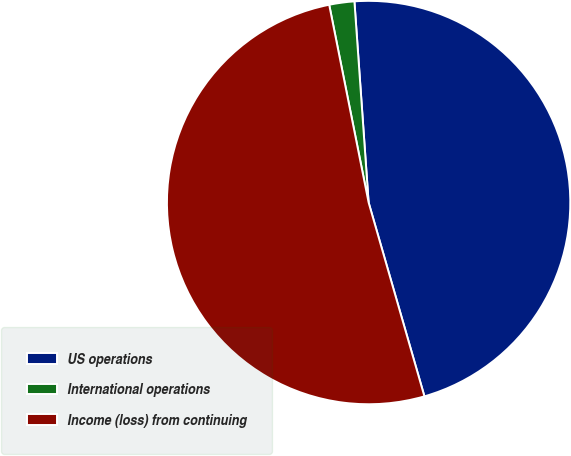Convert chart. <chart><loc_0><loc_0><loc_500><loc_500><pie_chart><fcel>US operations<fcel>International operations<fcel>Income (loss) from continuing<nl><fcel>46.66%<fcel>2.01%<fcel>51.33%<nl></chart> 